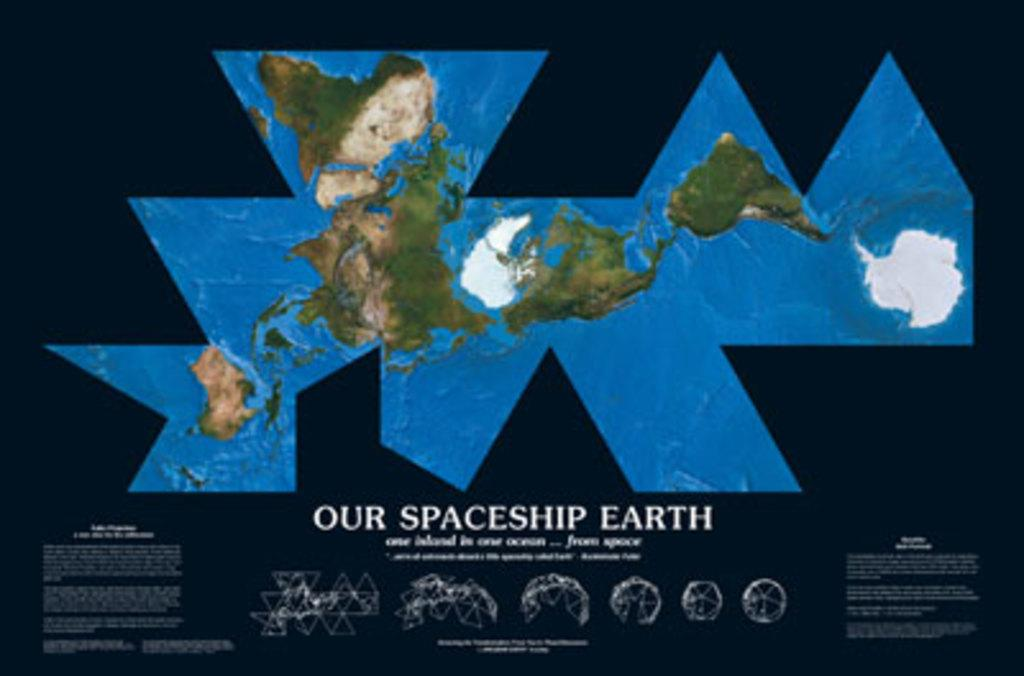<image>
Provide a brief description of the given image. a poster comemorating our spaceship earth in a graphic style 